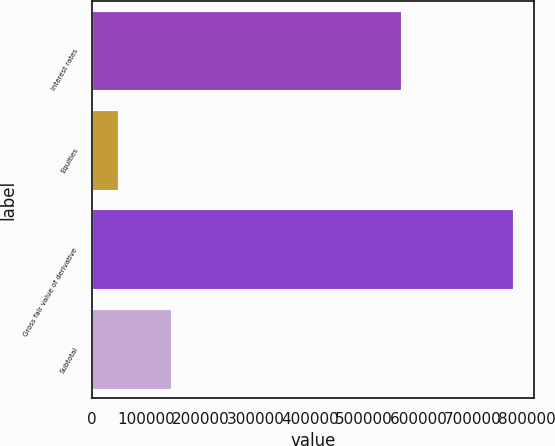Convert chart. <chart><loc_0><loc_0><loc_500><loc_500><bar_chart><fcel>Interest rates<fcel>Equities<fcel>Gross fair value of derivative<fcel>Subtotal<nl><fcel>568325<fcel>47160<fcel>774189<fcel>144502<nl></chart> 